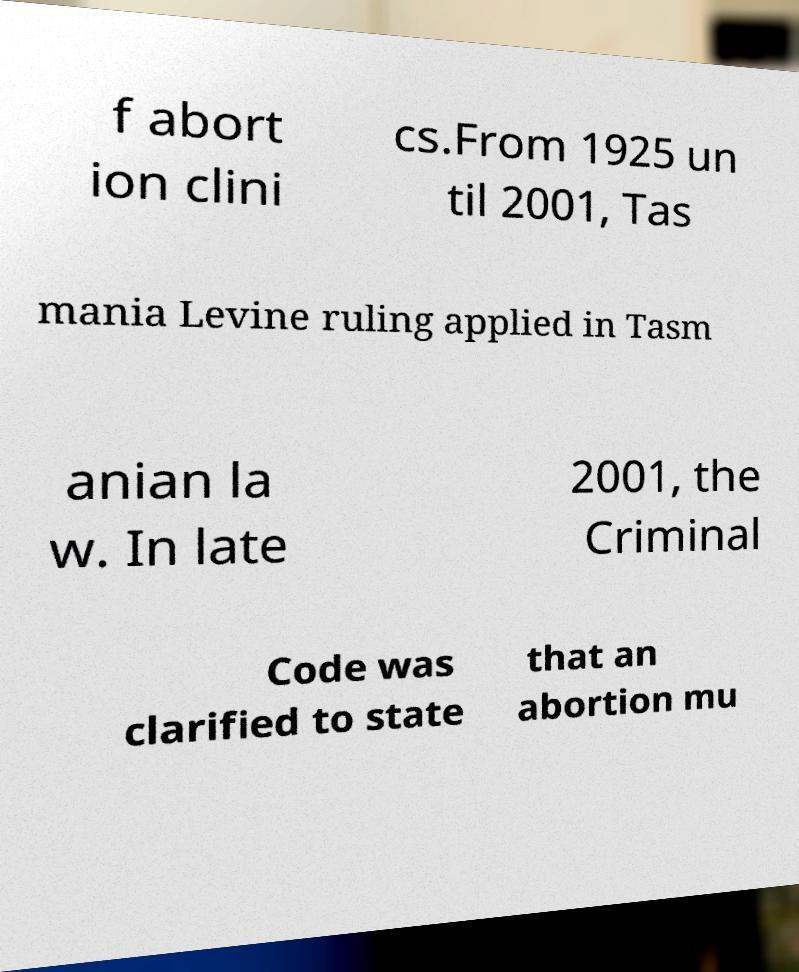Could you assist in decoding the text presented in this image and type it out clearly? f abort ion clini cs.From 1925 un til 2001, Tas mania Levine ruling applied in Tasm anian la w. In late 2001, the Criminal Code was clarified to state that an abortion mu 